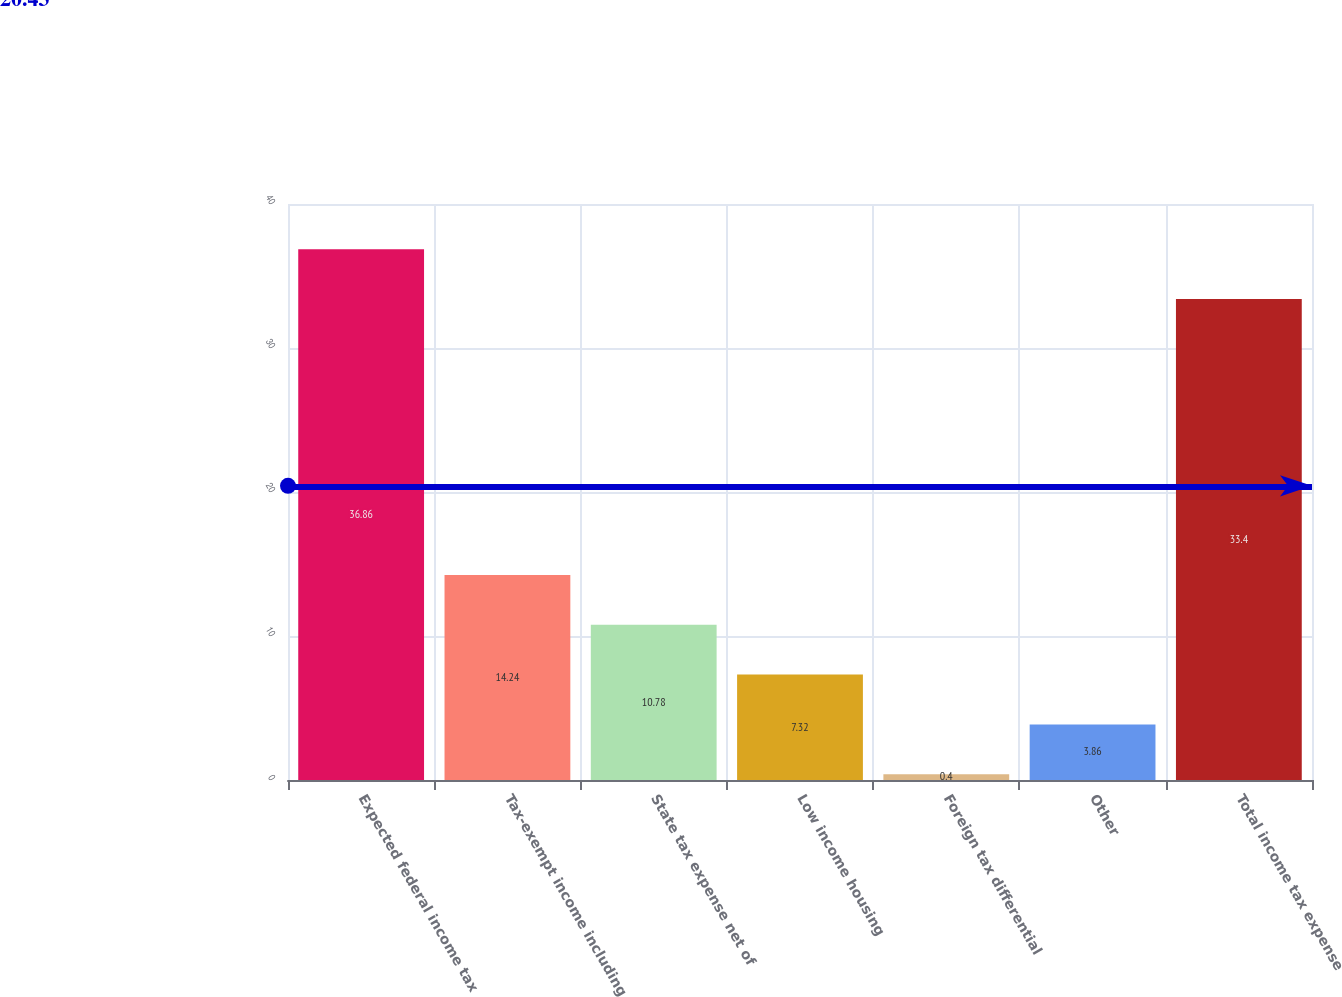Convert chart. <chart><loc_0><loc_0><loc_500><loc_500><bar_chart><fcel>Expected federal income tax<fcel>Tax-exempt income including<fcel>State tax expense net of<fcel>Low income housing<fcel>Foreign tax differential<fcel>Other<fcel>Total income tax expense<nl><fcel>36.86<fcel>14.24<fcel>10.78<fcel>7.32<fcel>0.4<fcel>3.86<fcel>33.4<nl></chart> 